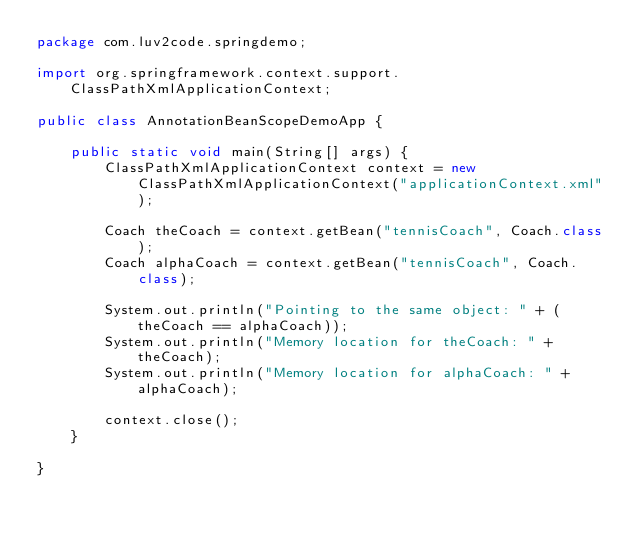<code> <loc_0><loc_0><loc_500><loc_500><_Java_>package com.luv2code.springdemo;

import org.springframework.context.support.ClassPathXmlApplicationContext;

public class AnnotationBeanScopeDemoApp {

	public static void main(String[] args) {
		ClassPathXmlApplicationContext context = new ClassPathXmlApplicationContext("applicationContext.xml");
		
		Coach theCoach = context.getBean("tennisCoach", Coach.class);
		Coach alphaCoach = context.getBean("tennisCoach", Coach.class);
		
		System.out.println("Pointing to the same object: " + (theCoach == alphaCoach));
		System.out.println("Memory location for theCoach: " + theCoach);
		System.out.println("Memory location for alphaCoach: " + alphaCoach);
		
		context.close();
	}

}
</code> 